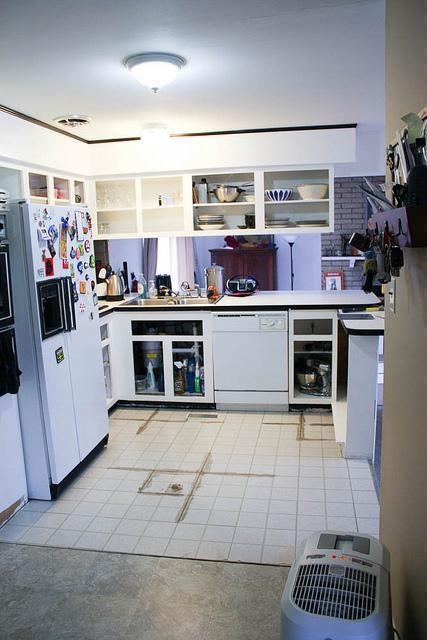What type of floor has been laid in the kitchen?
Choose the right answer from the provided options to respond to the question.
Options: Tyle, carpet, linoleum, hardwood. Hardwood. 